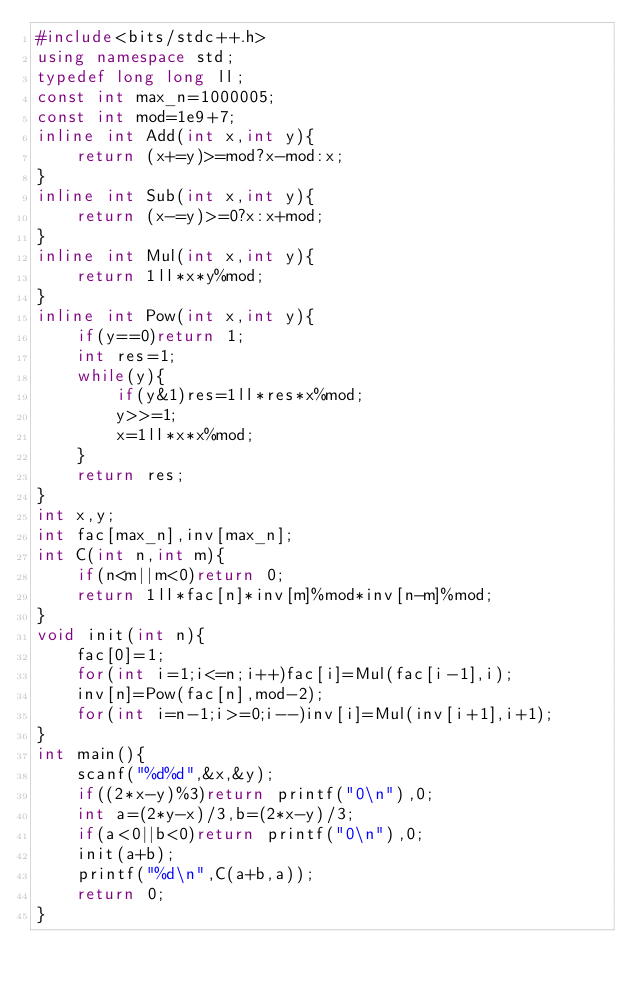Convert code to text. <code><loc_0><loc_0><loc_500><loc_500><_C++_>#include<bits/stdc++.h>
using namespace std;
typedef long long ll;
const int max_n=1000005;
const int mod=1e9+7;
inline int Add(int x,int y){
    return (x+=y)>=mod?x-mod:x;
}
inline int Sub(int x,int y){
    return (x-=y)>=0?x:x+mod;
}
inline int Mul(int x,int y){
    return 1ll*x*y%mod;
}
inline int Pow(int x,int y){
    if(y==0)return 1;
    int res=1;
    while(y){
        if(y&1)res=1ll*res*x%mod;
        y>>=1;
        x=1ll*x*x%mod;
    }
    return res;
}
int x,y;
int fac[max_n],inv[max_n];
int C(int n,int m){
    if(n<m||m<0)return 0;
    return 1ll*fac[n]*inv[m]%mod*inv[n-m]%mod;
}
void init(int n){
    fac[0]=1;
    for(int i=1;i<=n;i++)fac[i]=Mul(fac[i-1],i);
    inv[n]=Pow(fac[n],mod-2);
    for(int i=n-1;i>=0;i--)inv[i]=Mul(inv[i+1],i+1);
}
int main(){
    scanf("%d%d",&x,&y);
    if((2*x-y)%3)return printf("0\n"),0;
    int a=(2*y-x)/3,b=(2*x-y)/3;
    if(a<0||b<0)return printf("0\n"),0;
    init(a+b);
    printf("%d\n",C(a+b,a));
    return 0;
}</code> 